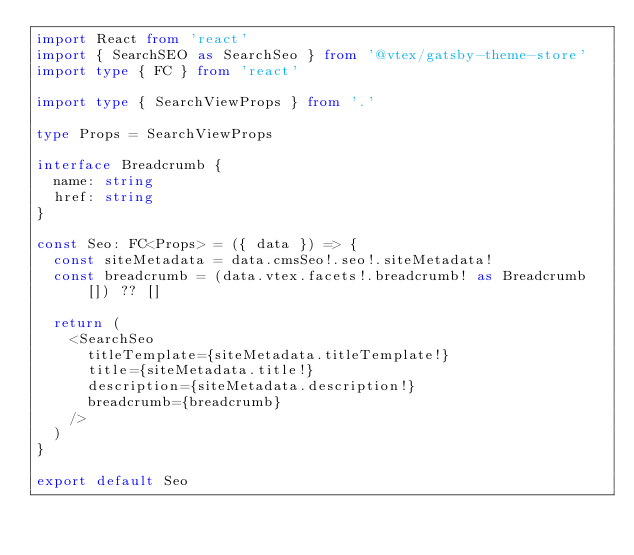<code> <loc_0><loc_0><loc_500><loc_500><_TypeScript_>import React from 'react'
import { SearchSEO as SearchSeo } from '@vtex/gatsby-theme-store'
import type { FC } from 'react'

import type { SearchViewProps } from '.'

type Props = SearchViewProps

interface Breadcrumb {
  name: string
  href: string
}

const Seo: FC<Props> = ({ data }) => {
  const siteMetadata = data.cmsSeo!.seo!.siteMetadata!
  const breadcrumb = (data.vtex.facets!.breadcrumb! as Breadcrumb[]) ?? []

  return (
    <SearchSeo
      titleTemplate={siteMetadata.titleTemplate!}
      title={siteMetadata.title!}
      description={siteMetadata.description!}
      breadcrumb={breadcrumb}
    />
  )
}

export default Seo
</code> 